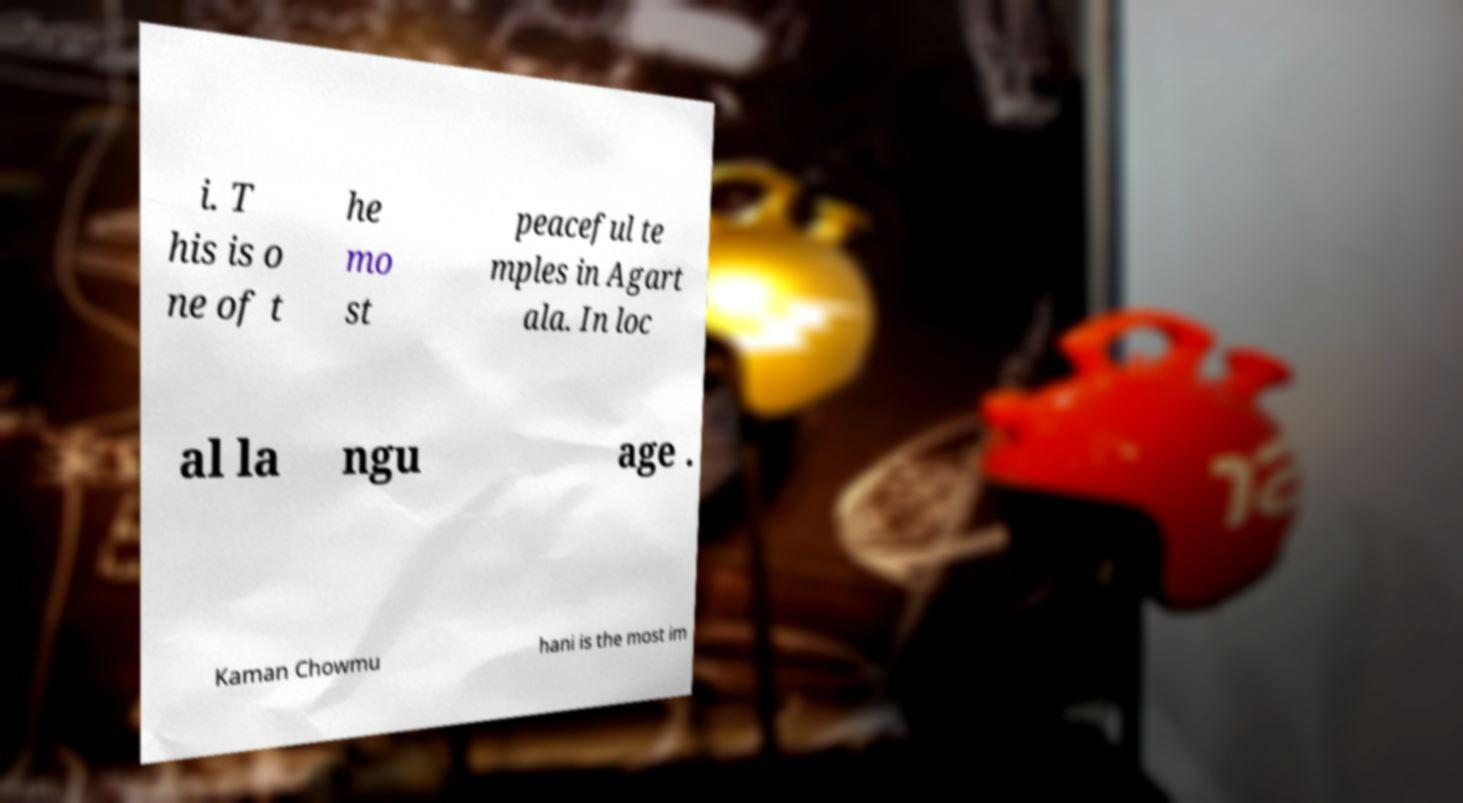What messages or text are displayed in this image? I need them in a readable, typed format. i. T his is o ne of t he mo st peaceful te mples in Agart ala. In loc al la ngu age . Kaman Chowmu hani is the most im 